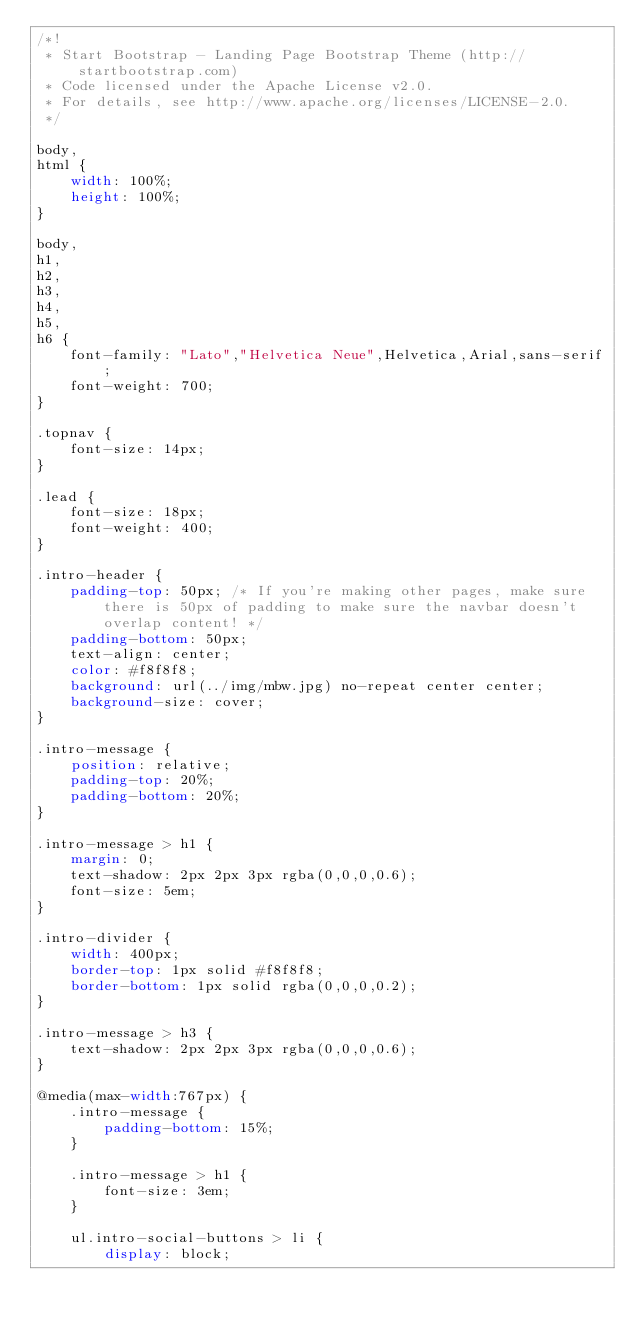<code> <loc_0><loc_0><loc_500><loc_500><_CSS_>/*!
 * Start Bootstrap - Landing Page Bootstrap Theme (http://startbootstrap.com)
 * Code licensed under the Apache License v2.0.
 * For details, see http://www.apache.org/licenses/LICENSE-2.0.
 */

body,
html {
    width: 100%;
    height: 100%;
}

body,
h1,
h2,
h3,
h4,
h5,
h6 {
    font-family: "Lato","Helvetica Neue",Helvetica,Arial,sans-serif;
    font-weight: 700;
}

.topnav {
    font-size: 14px; 
}

.lead {
    font-size: 18px;
    font-weight: 400;
}

.intro-header {
    padding-top: 50px; /* If you're making other pages, make sure there is 50px of padding to make sure the navbar doesn't overlap content! */
    padding-bottom: 50px;
    text-align: center;
    color: #f8f8f8;
    background: url(../img/mbw.jpg) no-repeat center center;
    background-size: cover;
}

.intro-message {
    position: relative;
    padding-top: 20%;
    padding-bottom: 20%;
}

.intro-message > h1 {
    margin: 0;
    text-shadow: 2px 2px 3px rgba(0,0,0,0.6);
    font-size: 5em;
}

.intro-divider {
    width: 400px;
    border-top: 1px solid #f8f8f8;
    border-bottom: 1px solid rgba(0,0,0,0.2);
}

.intro-message > h3 {
    text-shadow: 2px 2px 3px rgba(0,0,0,0.6);
}

@media(max-width:767px) {
    .intro-message {
        padding-bottom: 15%;
    }

    .intro-message > h1 {
        font-size: 3em;
    }

    ul.intro-social-buttons > li {
        display: block;</code> 